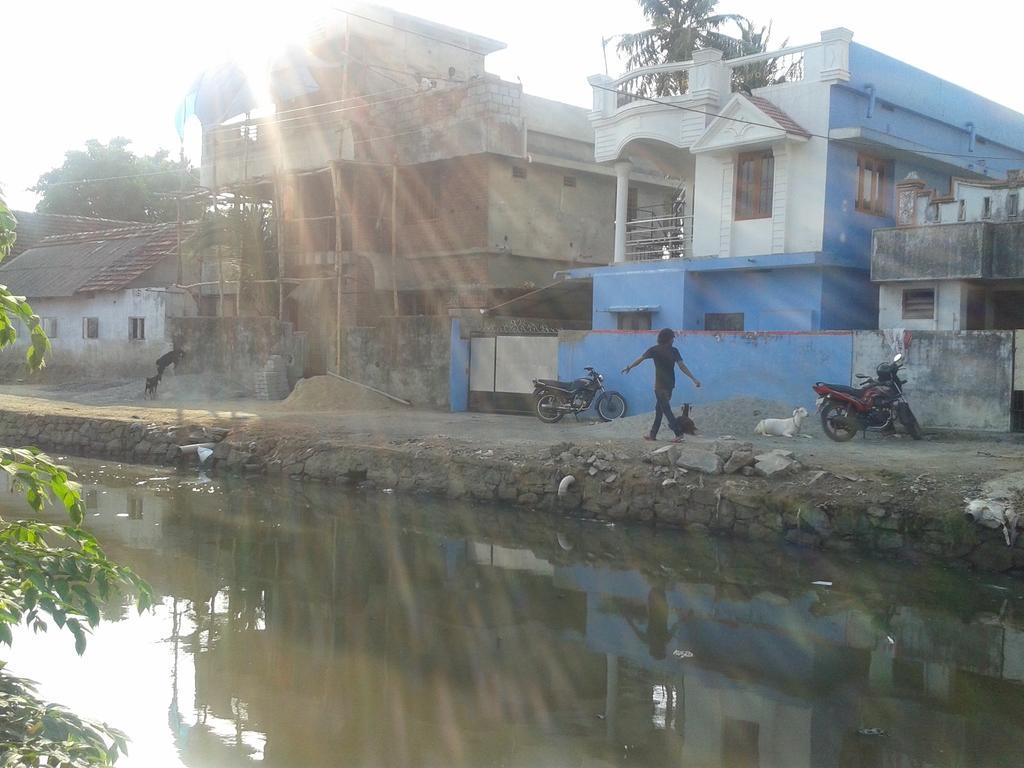Could you give a brief overview of what you see in this image? In this image on the left side we can see branches of a plant. We can see water. In the background there are houses, buildings, windows, doors, animals, bikes and sand on the ground, a person is walking on the ground, stones, few persons are on the building, trees and sky. 